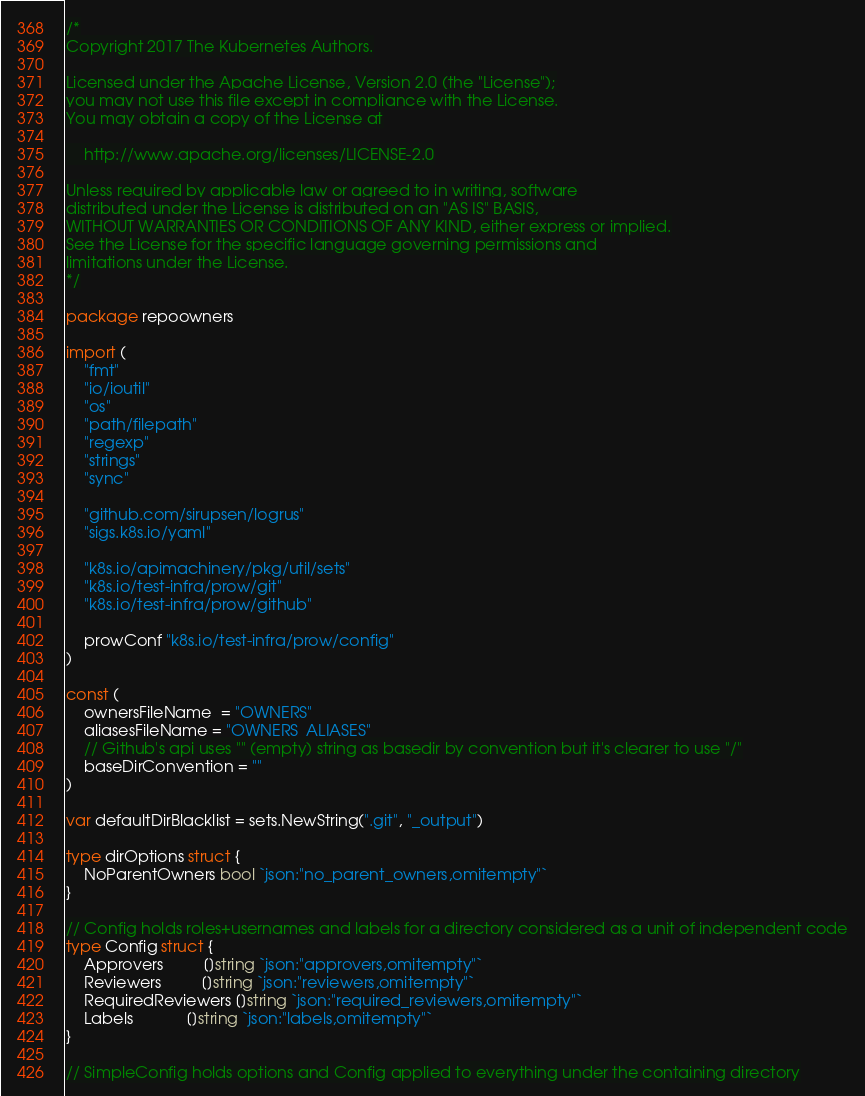Convert code to text. <code><loc_0><loc_0><loc_500><loc_500><_Go_>/*
Copyright 2017 The Kubernetes Authors.

Licensed under the Apache License, Version 2.0 (the "License");
you may not use this file except in compliance with the License.
You may obtain a copy of the License at

    http://www.apache.org/licenses/LICENSE-2.0

Unless required by applicable law or agreed to in writing, software
distributed under the License is distributed on an "AS IS" BASIS,
WITHOUT WARRANTIES OR CONDITIONS OF ANY KIND, either express or implied.
See the License for the specific language governing permissions and
limitations under the License.
*/

package repoowners

import (
	"fmt"
	"io/ioutil"
	"os"
	"path/filepath"
	"regexp"
	"strings"
	"sync"

	"github.com/sirupsen/logrus"
	"sigs.k8s.io/yaml"

	"k8s.io/apimachinery/pkg/util/sets"
	"k8s.io/test-infra/prow/git"
	"k8s.io/test-infra/prow/github"

	prowConf "k8s.io/test-infra/prow/config"
)

const (
	ownersFileName  = "OWNERS"
	aliasesFileName = "OWNERS_ALIASES"
	// Github's api uses "" (empty) string as basedir by convention but it's clearer to use "/"
	baseDirConvention = ""
)

var defaultDirBlacklist = sets.NewString(".git", "_output")

type dirOptions struct {
	NoParentOwners bool `json:"no_parent_owners,omitempty"`
}

// Config holds roles+usernames and labels for a directory considered as a unit of independent code
type Config struct {
	Approvers         []string `json:"approvers,omitempty"`
	Reviewers         []string `json:"reviewers,omitempty"`
	RequiredReviewers []string `json:"required_reviewers,omitempty"`
	Labels            []string `json:"labels,omitempty"`
}

// SimpleConfig holds options and Config applied to everything under the containing directory</code> 